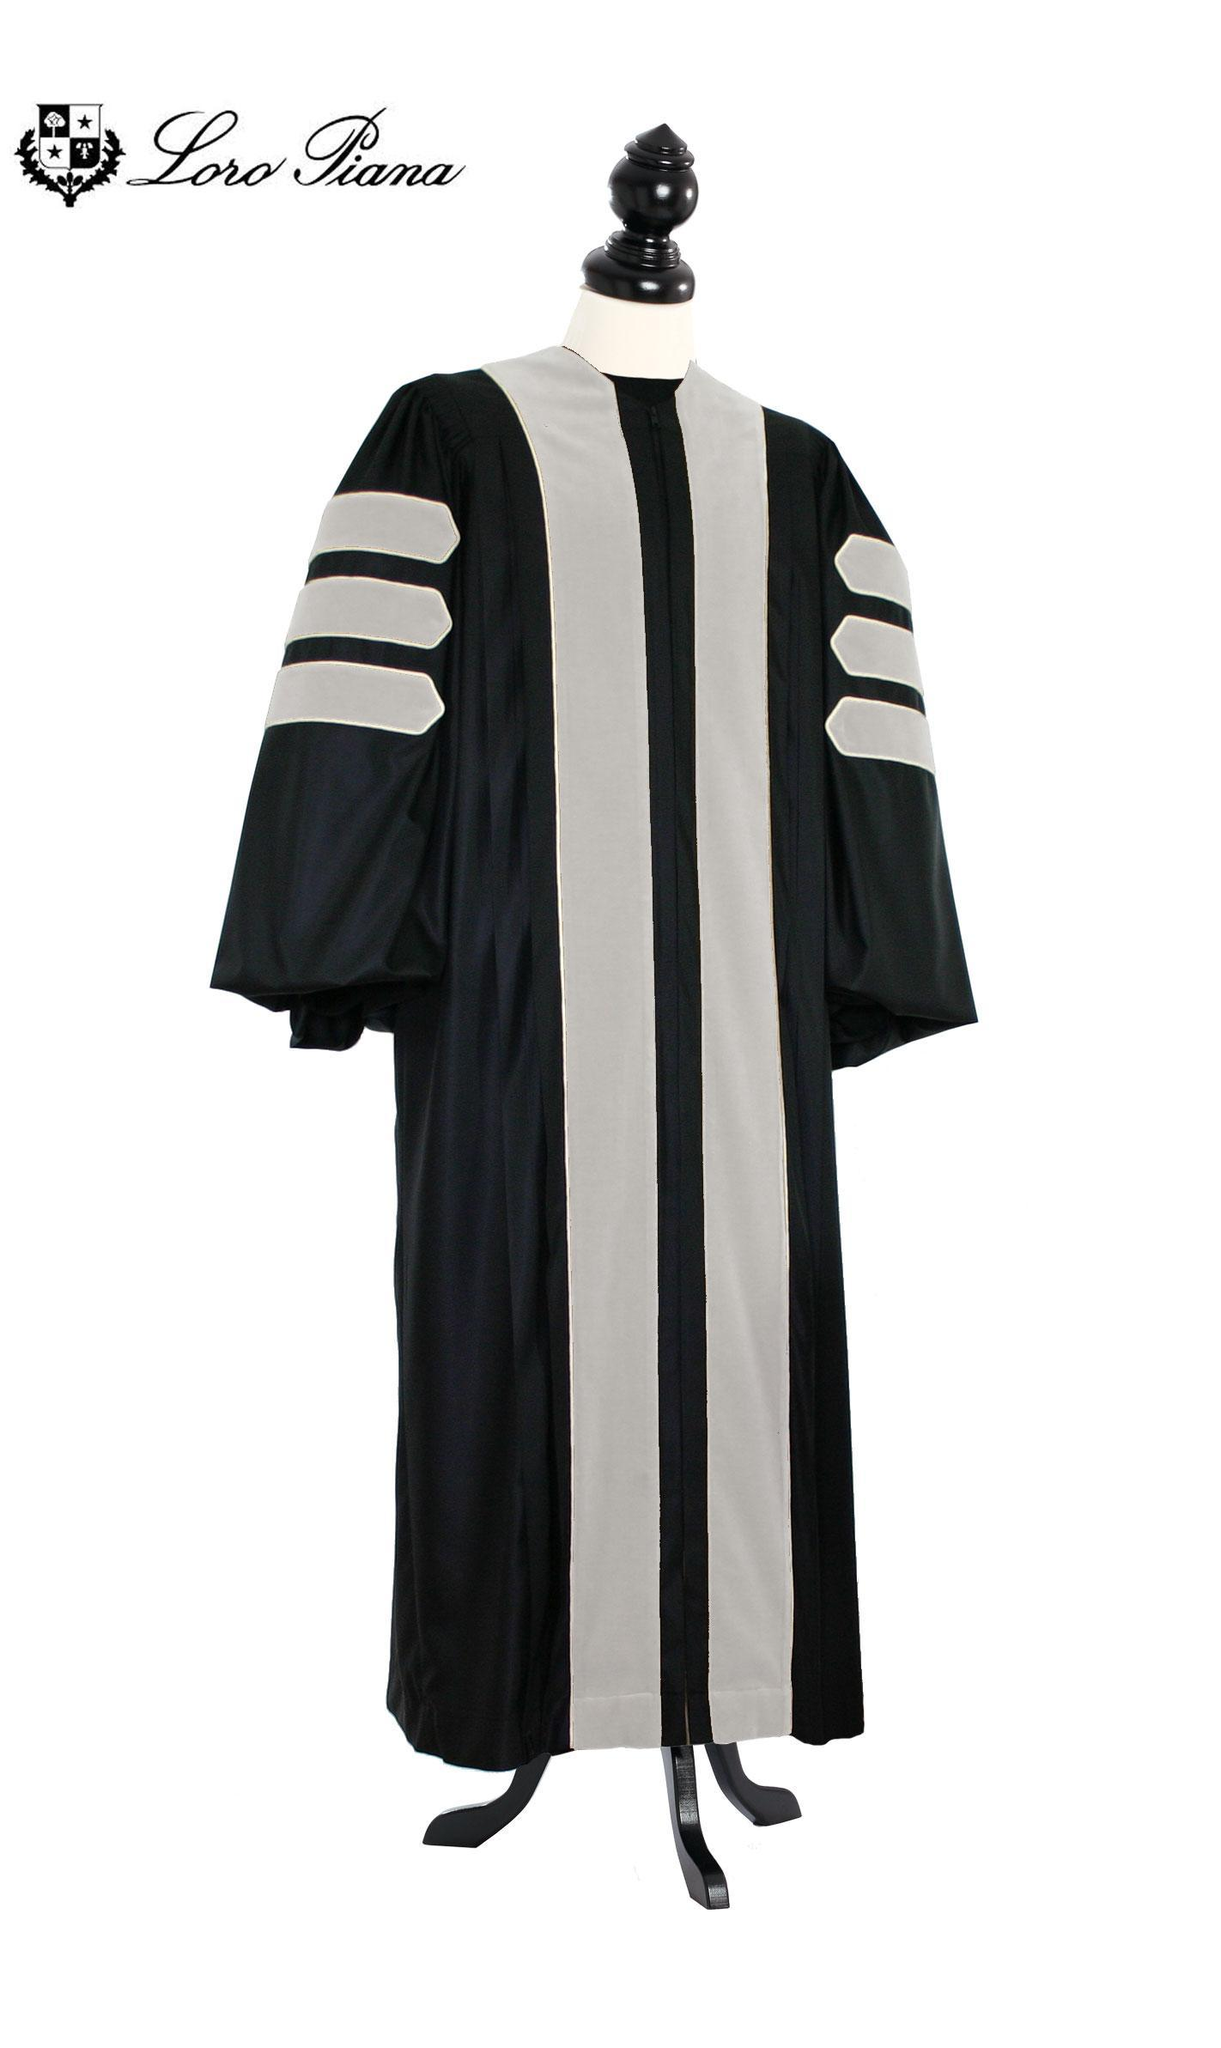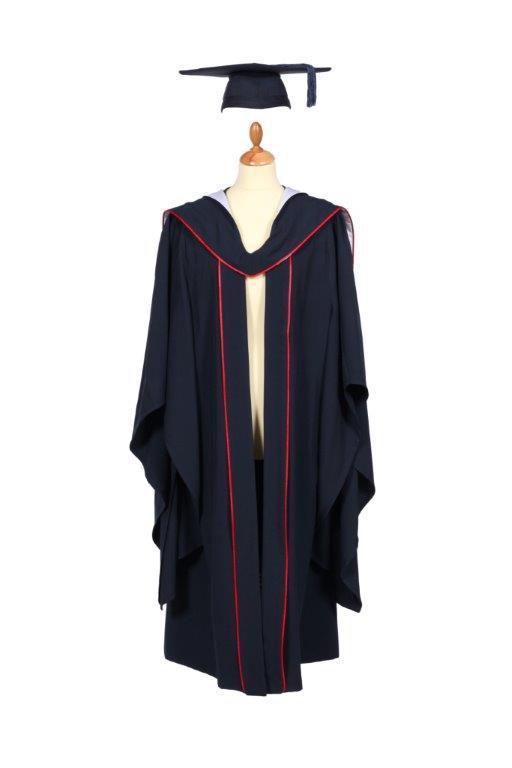The first image is the image on the left, the second image is the image on the right. Assess this claim about the two images: "At least one image shows predominantly black gown modeled by a human.". Correct or not? Answer yes or no. No. The first image is the image on the left, the second image is the image on the right. Analyze the images presented: Is the assertion "No graduation attire is modeled by a human, and at least one graduation robe is on a headless mannequin form." valid? Answer yes or no. Yes. 